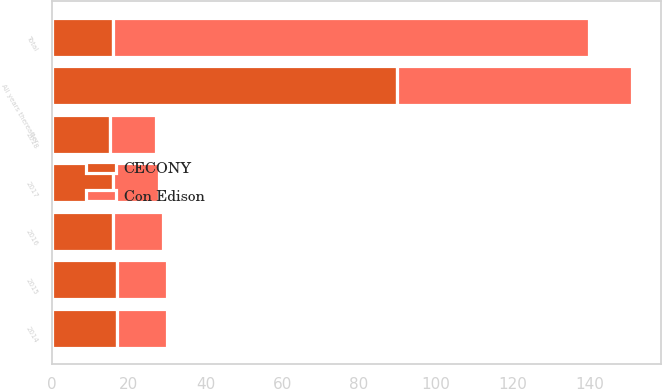Convert chart to OTSL. <chart><loc_0><loc_0><loc_500><loc_500><stacked_bar_chart><ecel><fcel>2014<fcel>2015<fcel>2016<fcel>2017<fcel>2018<fcel>All years thereafter<fcel>Total<nl><fcel>CECONY<fcel>17<fcel>17<fcel>16<fcel>16<fcel>15<fcel>90<fcel>16<nl><fcel>Con Edison<fcel>13<fcel>13<fcel>13<fcel>12<fcel>12<fcel>61<fcel>124<nl></chart> 